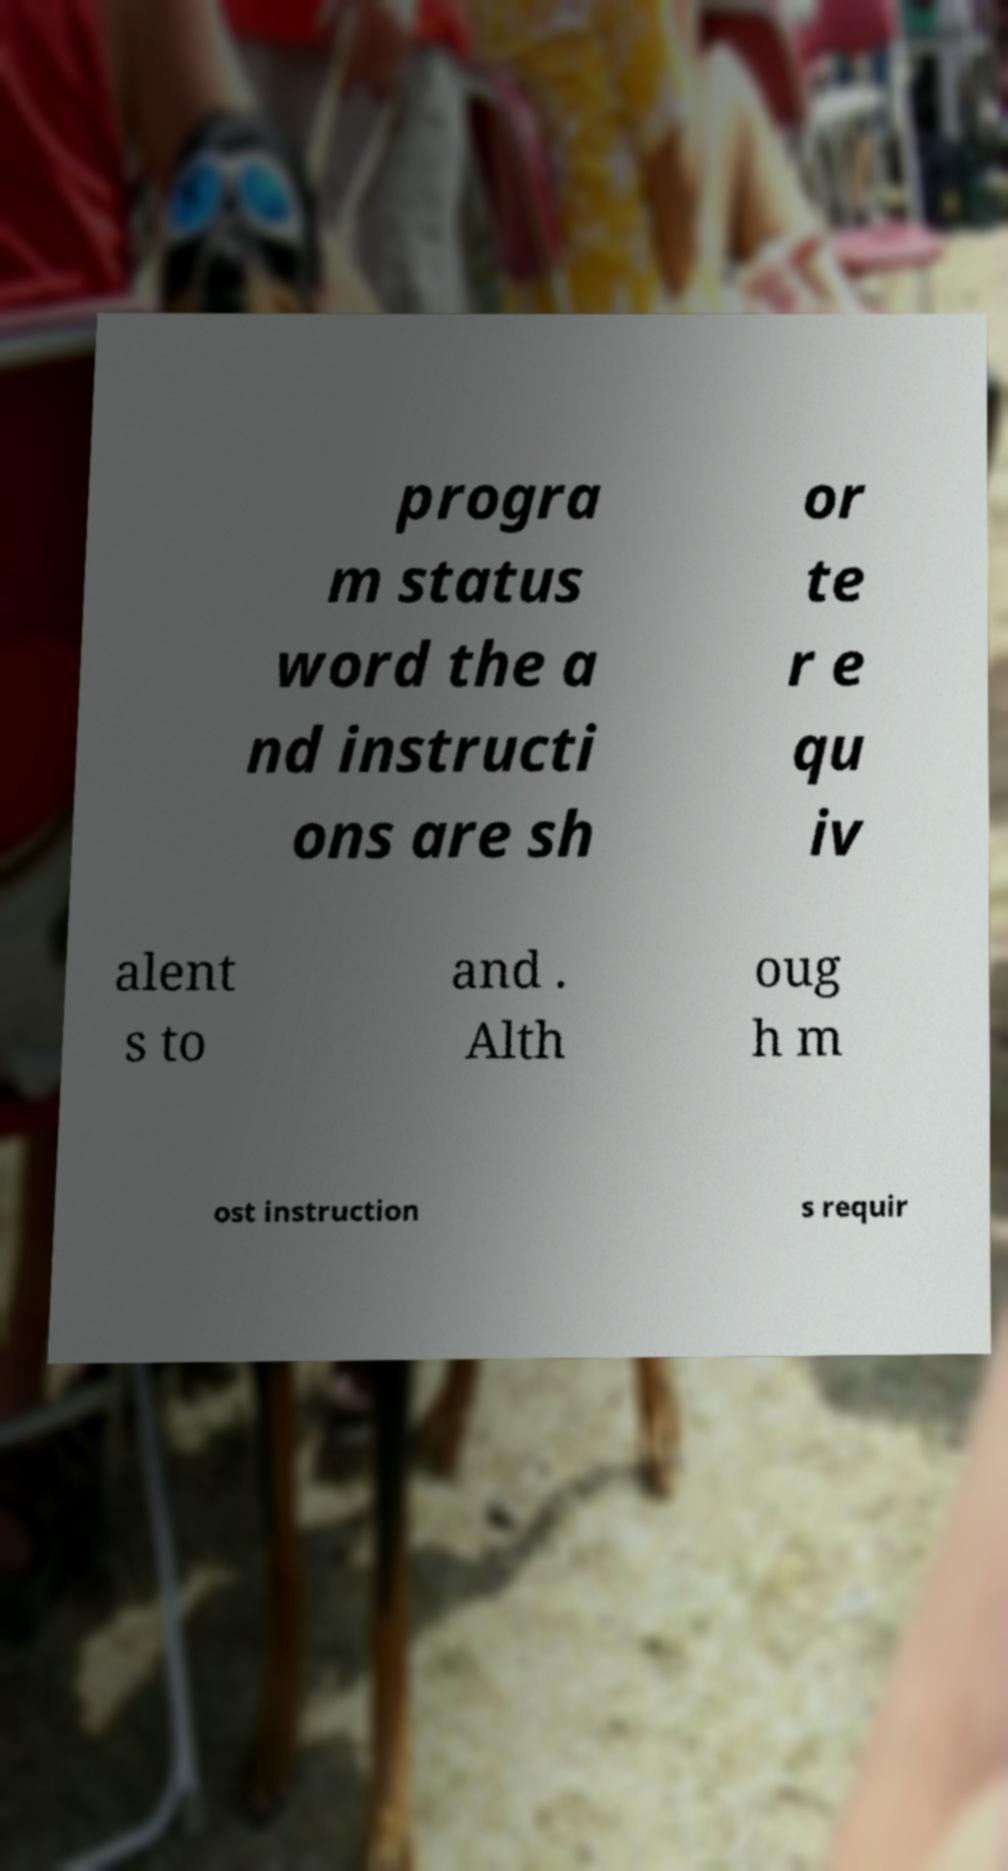There's text embedded in this image that I need extracted. Can you transcribe it verbatim? progra m status word the a nd instructi ons are sh or te r e qu iv alent s to and . Alth oug h m ost instruction s requir 